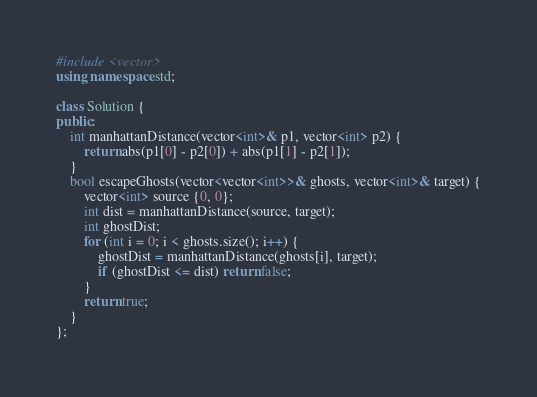<code> <loc_0><loc_0><loc_500><loc_500><_C++_>#include <vector>
using namespace std;

class Solution {
public:
    int manhattanDistance(vector<int>& p1, vector<int> p2) {
        return abs(p1[0] - p2[0]) + abs(p1[1] - p2[1]);
    }
    bool escapeGhosts(vector<vector<int>>& ghosts, vector<int>& target) {
        vector<int> source {0, 0};
        int dist = manhattanDistance(source, target);
        int ghostDist;
        for (int i = 0; i < ghosts.size(); i++) {
            ghostDist = manhattanDistance(ghosts[i], target);
            if (ghostDist <= dist) return false;
        }
        return true;
    }
};</code> 